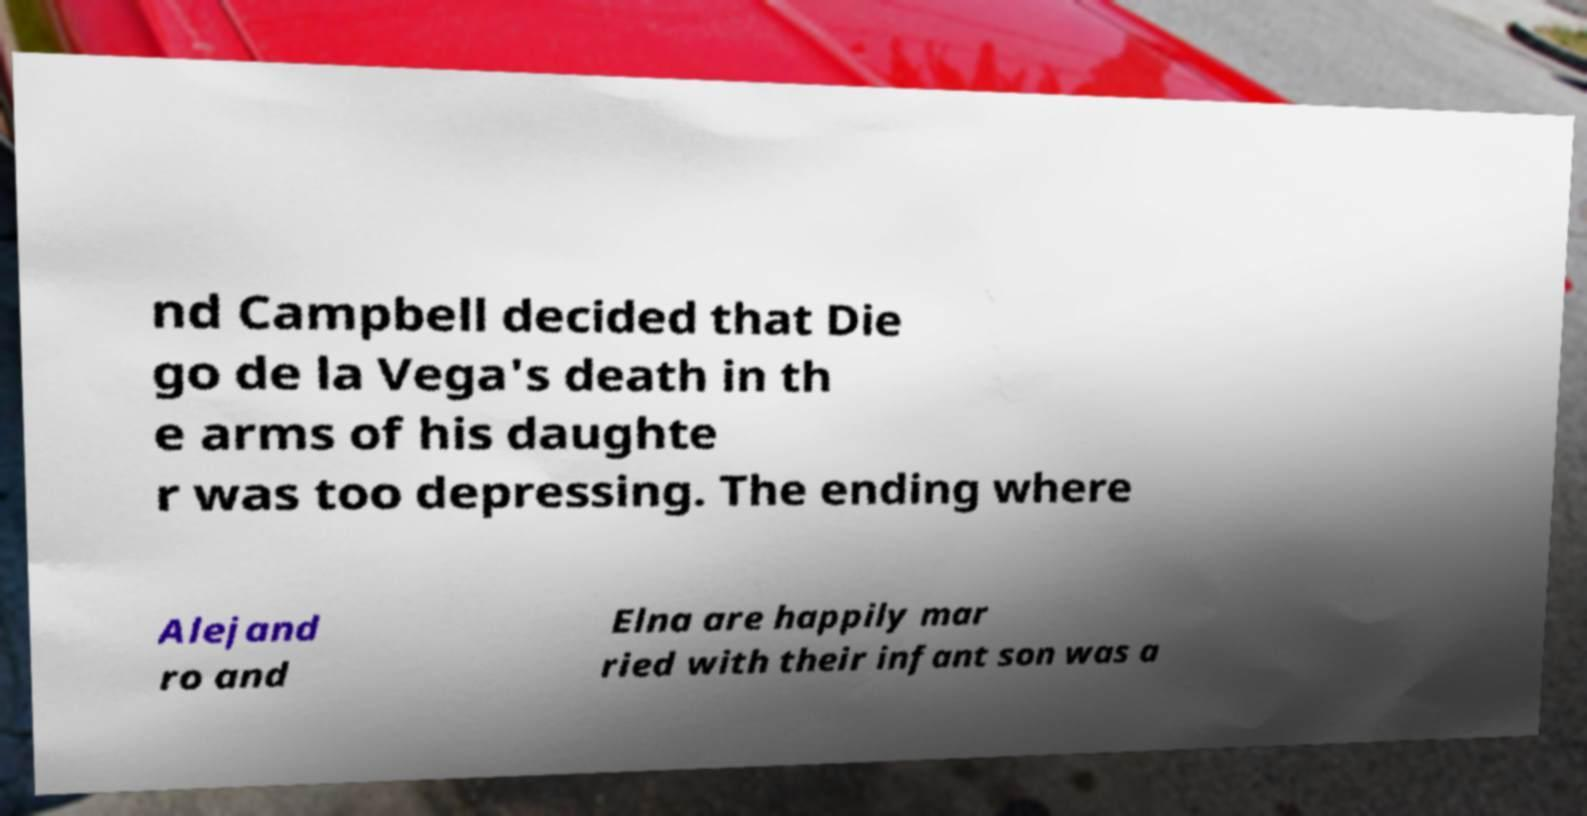There's text embedded in this image that I need extracted. Can you transcribe it verbatim? nd Campbell decided that Die go de la Vega's death in th e arms of his daughte r was too depressing. The ending where Alejand ro and Elna are happily mar ried with their infant son was a 